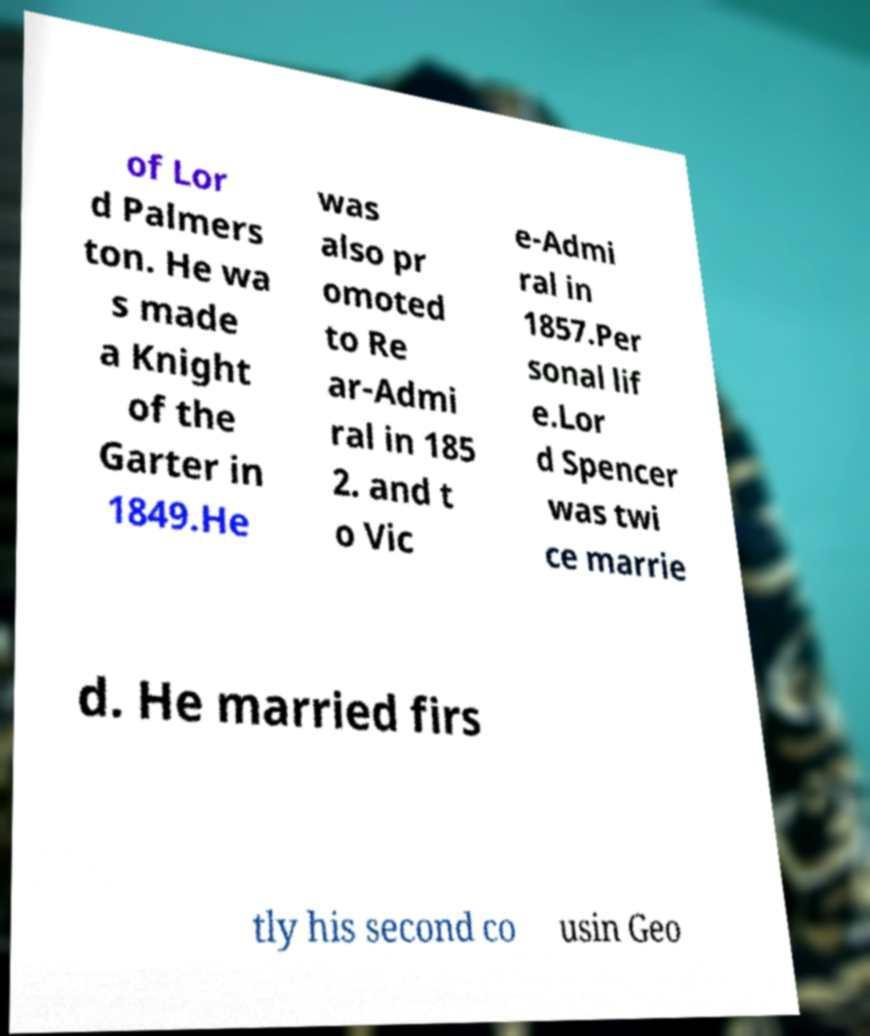Could you extract and type out the text from this image? of Lor d Palmers ton. He wa s made a Knight of the Garter in 1849.He was also pr omoted to Re ar-Admi ral in 185 2. and t o Vic e-Admi ral in 1857.Per sonal lif e.Lor d Spencer was twi ce marrie d. He married firs tly his second co usin Geo 